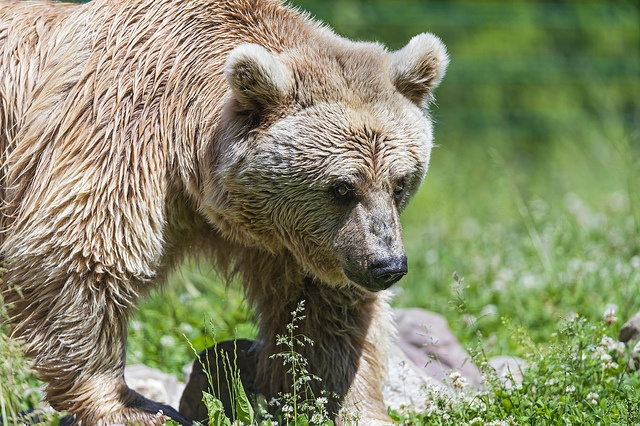Describe the objects in this image and their specific colors. I can see a bear in lightgray, black, darkgray, and gray tones in this image. 